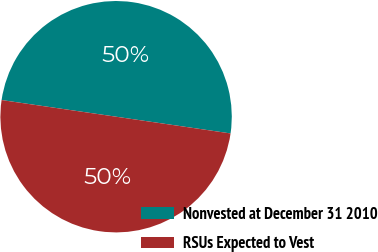Convert chart. <chart><loc_0><loc_0><loc_500><loc_500><pie_chart><fcel>Nonvested at December 31 2010<fcel>RSUs Expected to Vest<nl><fcel>50.01%<fcel>49.99%<nl></chart> 